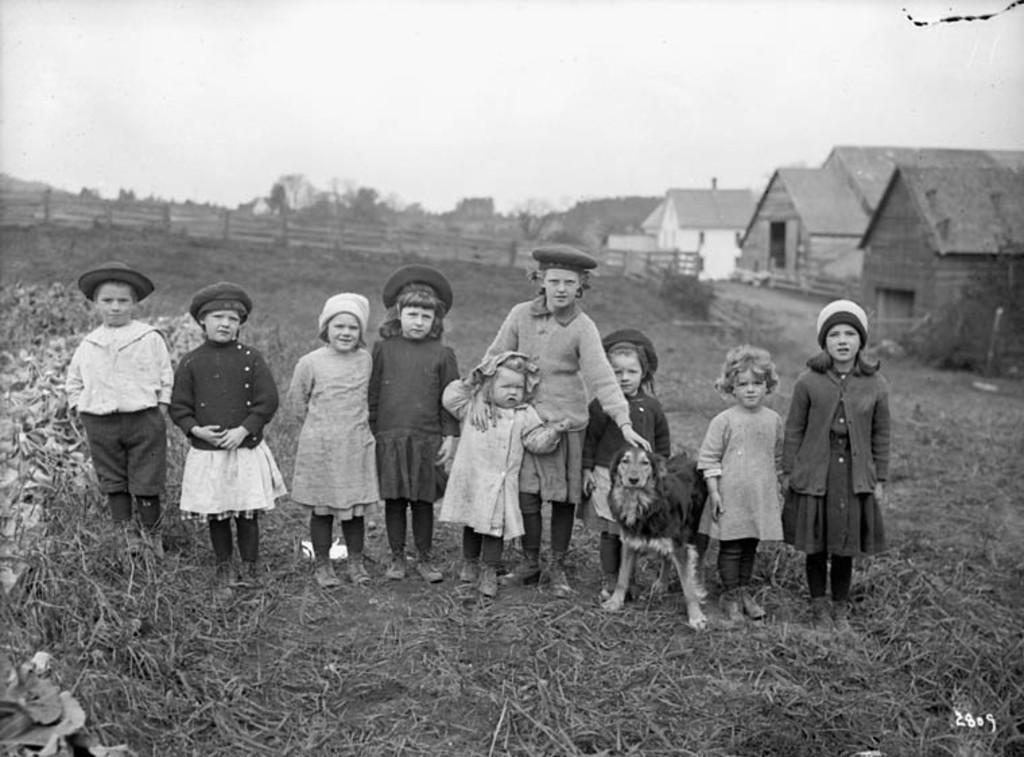Who is present in the image? There are children in the image. What are the children doing in the image? The children are standing with a dog. What can be seen in the distance in the image? There are houses and trees in the background of the image. What type of power source is visible in the image? There is no power source visible in the image; it features children standing with a dog and a background of houses and trees. 